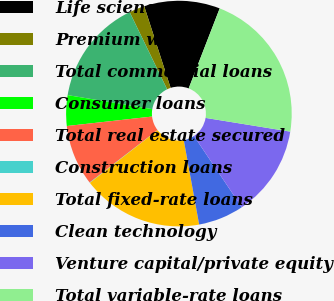<chart> <loc_0><loc_0><loc_500><loc_500><pie_chart><fcel>Life science<fcel>Premium wine<fcel>Total commercial loans<fcel>Consumer loans<fcel>Total real estate secured<fcel>Construction loans<fcel>Total fixed-rate loans<fcel>Clean technology<fcel>Venture capital/private equity<fcel>Total variable-rate loans<nl><fcel>10.86%<fcel>2.22%<fcel>15.19%<fcel>4.38%<fcel>8.7%<fcel>0.06%<fcel>17.35%<fcel>6.54%<fcel>13.03%<fcel>21.67%<nl></chart> 